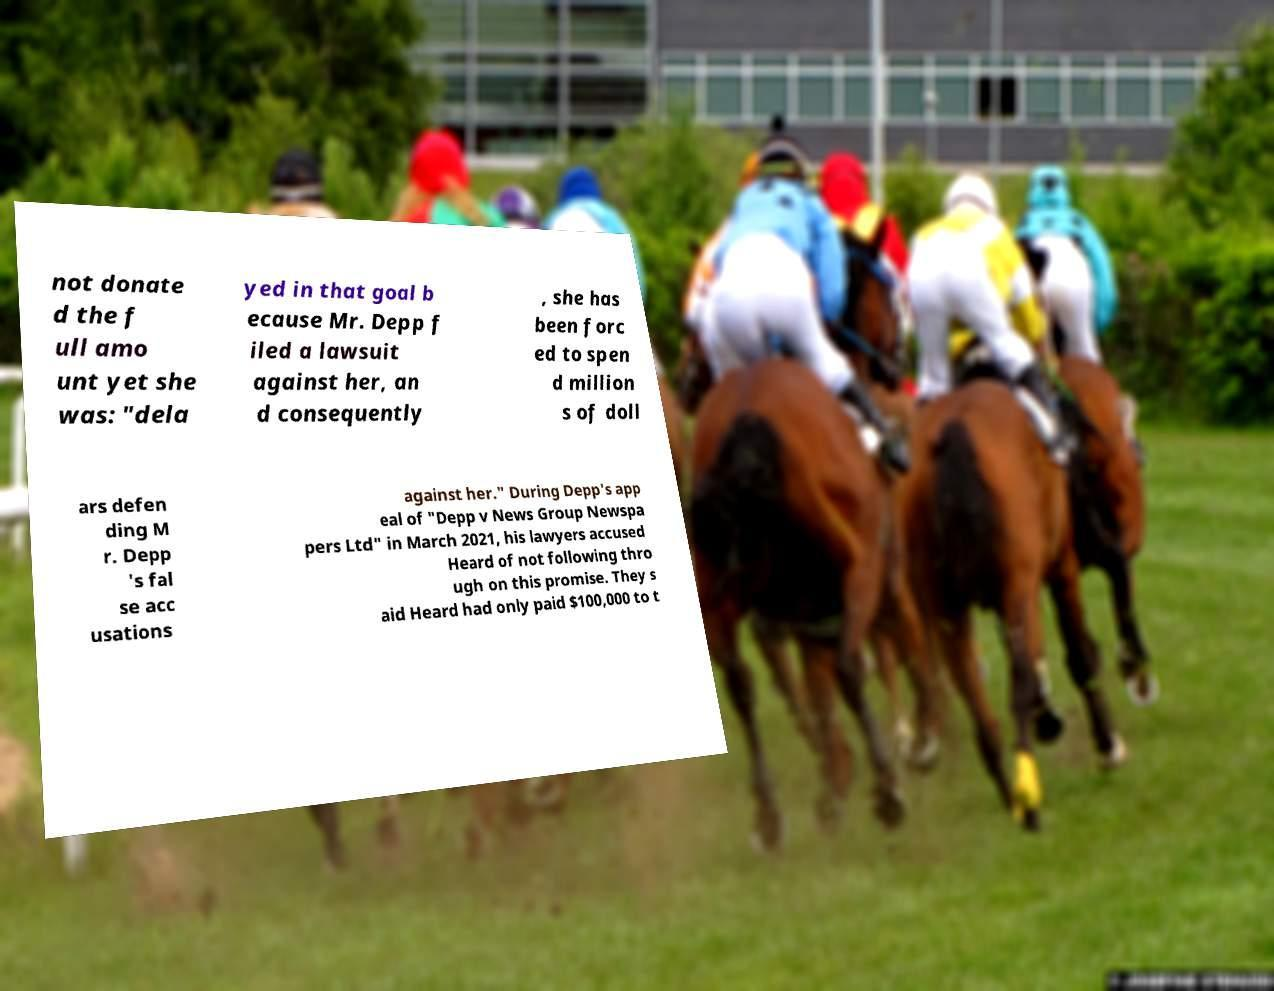Please read and relay the text visible in this image. What does it say? not donate d the f ull amo unt yet she was: "dela yed in that goal b ecause Mr. Depp f iled a lawsuit against her, an d consequently , she has been forc ed to spen d million s of doll ars defen ding M r. Depp 's fal se acc usations against her." During Depp's app eal of "Depp v News Group Newspa pers Ltd" in March 2021, his lawyers accused Heard of not following thro ugh on this promise. They s aid Heard had only paid $100,000 to t 